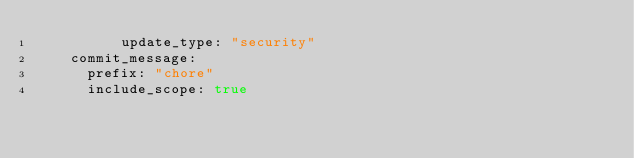<code> <loc_0><loc_0><loc_500><loc_500><_YAML_>          update_type: "security"
    commit_message:
      prefix: "chore"
      include_scope: true
</code> 